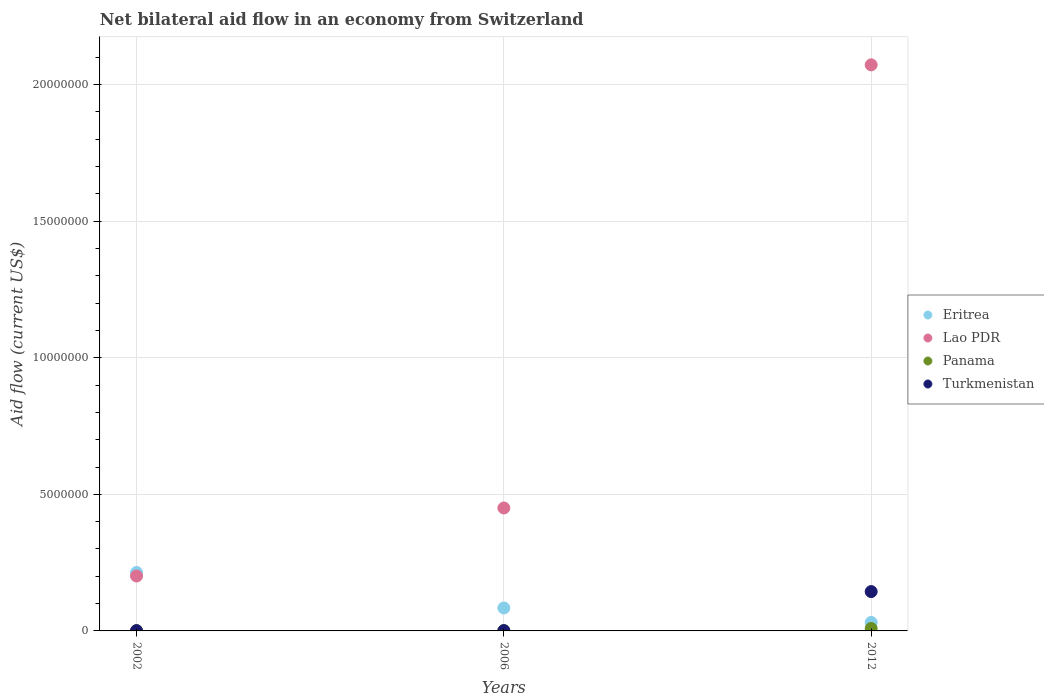Is the number of dotlines equal to the number of legend labels?
Your response must be concise. Yes. What is the net bilateral aid flow in Lao PDR in 2006?
Your answer should be very brief. 4.50e+06. Across all years, what is the maximum net bilateral aid flow in Lao PDR?
Provide a short and direct response. 2.07e+07. Across all years, what is the minimum net bilateral aid flow in Eritrea?
Ensure brevity in your answer.  3.10e+05. In which year was the net bilateral aid flow in Eritrea maximum?
Keep it short and to the point. 2002. In which year was the net bilateral aid flow in Lao PDR minimum?
Your answer should be compact. 2002. What is the total net bilateral aid flow in Turkmenistan in the graph?
Your response must be concise. 1.46e+06. What is the difference between the net bilateral aid flow in Panama in 2002 and the net bilateral aid flow in Lao PDR in 2012?
Offer a terse response. -2.07e+07. What is the average net bilateral aid flow in Turkmenistan per year?
Offer a very short reply. 4.87e+05. In the year 2006, what is the difference between the net bilateral aid flow in Eritrea and net bilateral aid flow in Turkmenistan?
Offer a terse response. 8.30e+05. What is the ratio of the net bilateral aid flow in Turkmenistan in 2002 to that in 2012?
Make the answer very short. 0.01. Is the difference between the net bilateral aid flow in Eritrea in 2006 and 2012 greater than the difference between the net bilateral aid flow in Turkmenistan in 2006 and 2012?
Ensure brevity in your answer.  Yes. What is the difference between the highest and the lowest net bilateral aid flow in Turkmenistan?
Keep it short and to the point. 1.43e+06. In how many years, is the net bilateral aid flow in Eritrea greater than the average net bilateral aid flow in Eritrea taken over all years?
Give a very brief answer. 1. Is the net bilateral aid flow in Turkmenistan strictly less than the net bilateral aid flow in Panama over the years?
Your answer should be compact. No. How many dotlines are there?
Provide a short and direct response. 4. How many years are there in the graph?
Keep it short and to the point. 3. What is the difference between two consecutive major ticks on the Y-axis?
Offer a terse response. 5.00e+06. Are the values on the major ticks of Y-axis written in scientific E-notation?
Ensure brevity in your answer.  No. Does the graph contain grids?
Ensure brevity in your answer.  Yes. Where does the legend appear in the graph?
Provide a succinct answer. Center right. How are the legend labels stacked?
Your answer should be compact. Vertical. What is the title of the graph?
Ensure brevity in your answer.  Net bilateral aid flow in an economy from Switzerland. Does "Sudan" appear as one of the legend labels in the graph?
Your answer should be compact. No. What is the label or title of the X-axis?
Your answer should be compact. Years. What is the label or title of the Y-axis?
Offer a terse response. Aid flow (current US$). What is the Aid flow (current US$) in Eritrea in 2002?
Provide a short and direct response. 2.14e+06. What is the Aid flow (current US$) in Lao PDR in 2002?
Your response must be concise. 2.01e+06. What is the Aid flow (current US$) of Panama in 2002?
Your answer should be very brief. 10000. What is the Aid flow (current US$) of Turkmenistan in 2002?
Offer a terse response. 10000. What is the Aid flow (current US$) in Eritrea in 2006?
Keep it short and to the point. 8.40e+05. What is the Aid flow (current US$) in Lao PDR in 2006?
Offer a very short reply. 4.50e+06. What is the Aid flow (current US$) of Turkmenistan in 2006?
Your answer should be very brief. 10000. What is the Aid flow (current US$) of Eritrea in 2012?
Give a very brief answer. 3.10e+05. What is the Aid flow (current US$) in Lao PDR in 2012?
Your response must be concise. 2.07e+07. What is the Aid flow (current US$) of Panama in 2012?
Offer a terse response. 9.00e+04. What is the Aid flow (current US$) of Turkmenistan in 2012?
Your answer should be compact. 1.44e+06. Across all years, what is the maximum Aid flow (current US$) of Eritrea?
Ensure brevity in your answer.  2.14e+06. Across all years, what is the maximum Aid flow (current US$) in Lao PDR?
Provide a succinct answer. 2.07e+07. Across all years, what is the maximum Aid flow (current US$) in Panama?
Ensure brevity in your answer.  9.00e+04. Across all years, what is the maximum Aid flow (current US$) of Turkmenistan?
Offer a very short reply. 1.44e+06. Across all years, what is the minimum Aid flow (current US$) in Lao PDR?
Your answer should be very brief. 2.01e+06. Across all years, what is the minimum Aid flow (current US$) in Panama?
Your answer should be very brief. 10000. Across all years, what is the minimum Aid flow (current US$) in Turkmenistan?
Your answer should be very brief. 10000. What is the total Aid flow (current US$) in Eritrea in the graph?
Give a very brief answer. 3.29e+06. What is the total Aid flow (current US$) of Lao PDR in the graph?
Your answer should be compact. 2.72e+07. What is the total Aid flow (current US$) of Panama in the graph?
Your response must be concise. 1.10e+05. What is the total Aid flow (current US$) of Turkmenistan in the graph?
Your response must be concise. 1.46e+06. What is the difference between the Aid flow (current US$) in Eritrea in 2002 and that in 2006?
Keep it short and to the point. 1.30e+06. What is the difference between the Aid flow (current US$) of Lao PDR in 2002 and that in 2006?
Give a very brief answer. -2.49e+06. What is the difference between the Aid flow (current US$) in Panama in 2002 and that in 2006?
Provide a short and direct response. 0. What is the difference between the Aid flow (current US$) in Eritrea in 2002 and that in 2012?
Give a very brief answer. 1.83e+06. What is the difference between the Aid flow (current US$) in Lao PDR in 2002 and that in 2012?
Offer a very short reply. -1.87e+07. What is the difference between the Aid flow (current US$) in Panama in 2002 and that in 2012?
Offer a very short reply. -8.00e+04. What is the difference between the Aid flow (current US$) in Turkmenistan in 2002 and that in 2012?
Offer a very short reply. -1.43e+06. What is the difference between the Aid flow (current US$) in Eritrea in 2006 and that in 2012?
Offer a terse response. 5.30e+05. What is the difference between the Aid flow (current US$) in Lao PDR in 2006 and that in 2012?
Offer a terse response. -1.62e+07. What is the difference between the Aid flow (current US$) in Panama in 2006 and that in 2012?
Ensure brevity in your answer.  -8.00e+04. What is the difference between the Aid flow (current US$) in Turkmenistan in 2006 and that in 2012?
Ensure brevity in your answer.  -1.43e+06. What is the difference between the Aid flow (current US$) of Eritrea in 2002 and the Aid flow (current US$) of Lao PDR in 2006?
Provide a short and direct response. -2.36e+06. What is the difference between the Aid flow (current US$) of Eritrea in 2002 and the Aid flow (current US$) of Panama in 2006?
Give a very brief answer. 2.13e+06. What is the difference between the Aid flow (current US$) in Eritrea in 2002 and the Aid flow (current US$) in Turkmenistan in 2006?
Offer a very short reply. 2.13e+06. What is the difference between the Aid flow (current US$) in Lao PDR in 2002 and the Aid flow (current US$) in Panama in 2006?
Offer a terse response. 2.00e+06. What is the difference between the Aid flow (current US$) of Eritrea in 2002 and the Aid flow (current US$) of Lao PDR in 2012?
Offer a very short reply. -1.86e+07. What is the difference between the Aid flow (current US$) of Eritrea in 2002 and the Aid flow (current US$) of Panama in 2012?
Make the answer very short. 2.05e+06. What is the difference between the Aid flow (current US$) of Eritrea in 2002 and the Aid flow (current US$) of Turkmenistan in 2012?
Make the answer very short. 7.00e+05. What is the difference between the Aid flow (current US$) in Lao PDR in 2002 and the Aid flow (current US$) in Panama in 2012?
Your response must be concise. 1.92e+06. What is the difference between the Aid flow (current US$) of Lao PDR in 2002 and the Aid flow (current US$) of Turkmenistan in 2012?
Your response must be concise. 5.70e+05. What is the difference between the Aid flow (current US$) in Panama in 2002 and the Aid flow (current US$) in Turkmenistan in 2012?
Your answer should be very brief. -1.43e+06. What is the difference between the Aid flow (current US$) of Eritrea in 2006 and the Aid flow (current US$) of Lao PDR in 2012?
Provide a succinct answer. -1.99e+07. What is the difference between the Aid flow (current US$) of Eritrea in 2006 and the Aid flow (current US$) of Panama in 2012?
Ensure brevity in your answer.  7.50e+05. What is the difference between the Aid flow (current US$) of Eritrea in 2006 and the Aid flow (current US$) of Turkmenistan in 2012?
Make the answer very short. -6.00e+05. What is the difference between the Aid flow (current US$) in Lao PDR in 2006 and the Aid flow (current US$) in Panama in 2012?
Offer a terse response. 4.41e+06. What is the difference between the Aid flow (current US$) in Lao PDR in 2006 and the Aid flow (current US$) in Turkmenistan in 2012?
Your response must be concise. 3.06e+06. What is the difference between the Aid flow (current US$) in Panama in 2006 and the Aid flow (current US$) in Turkmenistan in 2012?
Give a very brief answer. -1.43e+06. What is the average Aid flow (current US$) in Eritrea per year?
Keep it short and to the point. 1.10e+06. What is the average Aid flow (current US$) of Lao PDR per year?
Offer a terse response. 9.08e+06. What is the average Aid flow (current US$) of Panama per year?
Your answer should be very brief. 3.67e+04. What is the average Aid flow (current US$) of Turkmenistan per year?
Provide a short and direct response. 4.87e+05. In the year 2002, what is the difference between the Aid flow (current US$) in Eritrea and Aid flow (current US$) in Panama?
Your response must be concise. 2.13e+06. In the year 2002, what is the difference between the Aid flow (current US$) in Eritrea and Aid flow (current US$) in Turkmenistan?
Give a very brief answer. 2.13e+06. In the year 2006, what is the difference between the Aid flow (current US$) in Eritrea and Aid flow (current US$) in Lao PDR?
Provide a succinct answer. -3.66e+06. In the year 2006, what is the difference between the Aid flow (current US$) of Eritrea and Aid flow (current US$) of Panama?
Your response must be concise. 8.30e+05. In the year 2006, what is the difference between the Aid flow (current US$) in Eritrea and Aid flow (current US$) in Turkmenistan?
Your answer should be compact. 8.30e+05. In the year 2006, what is the difference between the Aid flow (current US$) in Lao PDR and Aid flow (current US$) in Panama?
Ensure brevity in your answer.  4.49e+06. In the year 2006, what is the difference between the Aid flow (current US$) of Lao PDR and Aid flow (current US$) of Turkmenistan?
Provide a succinct answer. 4.49e+06. In the year 2012, what is the difference between the Aid flow (current US$) in Eritrea and Aid flow (current US$) in Lao PDR?
Ensure brevity in your answer.  -2.04e+07. In the year 2012, what is the difference between the Aid flow (current US$) of Eritrea and Aid flow (current US$) of Panama?
Your answer should be compact. 2.20e+05. In the year 2012, what is the difference between the Aid flow (current US$) of Eritrea and Aid flow (current US$) of Turkmenistan?
Provide a succinct answer. -1.13e+06. In the year 2012, what is the difference between the Aid flow (current US$) in Lao PDR and Aid flow (current US$) in Panama?
Offer a terse response. 2.06e+07. In the year 2012, what is the difference between the Aid flow (current US$) of Lao PDR and Aid flow (current US$) of Turkmenistan?
Your response must be concise. 1.93e+07. In the year 2012, what is the difference between the Aid flow (current US$) of Panama and Aid flow (current US$) of Turkmenistan?
Give a very brief answer. -1.35e+06. What is the ratio of the Aid flow (current US$) in Eritrea in 2002 to that in 2006?
Your answer should be compact. 2.55. What is the ratio of the Aid flow (current US$) in Lao PDR in 2002 to that in 2006?
Your response must be concise. 0.45. What is the ratio of the Aid flow (current US$) of Panama in 2002 to that in 2006?
Ensure brevity in your answer.  1. What is the ratio of the Aid flow (current US$) of Eritrea in 2002 to that in 2012?
Your answer should be very brief. 6.9. What is the ratio of the Aid flow (current US$) of Lao PDR in 2002 to that in 2012?
Provide a short and direct response. 0.1. What is the ratio of the Aid flow (current US$) of Turkmenistan in 2002 to that in 2012?
Ensure brevity in your answer.  0.01. What is the ratio of the Aid flow (current US$) in Eritrea in 2006 to that in 2012?
Provide a succinct answer. 2.71. What is the ratio of the Aid flow (current US$) in Lao PDR in 2006 to that in 2012?
Give a very brief answer. 0.22. What is the ratio of the Aid flow (current US$) of Panama in 2006 to that in 2012?
Make the answer very short. 0.11. What is the ratio of the Aid flow (current US$) of Turkmenistan in 2006 to that in 2012?
Offer a terse response. 0.01. What is the difference between the highest and the second highest Aid flow (current US$) in Eritrea?
Your response must be concise. 1.30e+06. What is the difference between the highest and the second highest Aid flow (current US$) in Lao PDR?
Give a very brief answer. 1.62e+07. What is the difference between the highest and the second highest Aid flow (current US$) of Turkmenistan?
Offer a very short reply. 1.43e+06. What is the difference between the highest and the lowest Aid flow (current US$) in Eritrea?
Keep it short and to the point. 1.83e+06. What is the difference between the highest and the lowest Aid flow (current US$) of Lao PDR?
Make the answer very short. 1.87e+07. What is the difference between the highest and the lowest Aid flow (current US$) of Panama?
Your answer should be very brief. 8.00e+04. What is the difference between the highest and the lowest Aid flow (current US$) in Turkmenistan?
Your response must be concise. 1.43e+06. 